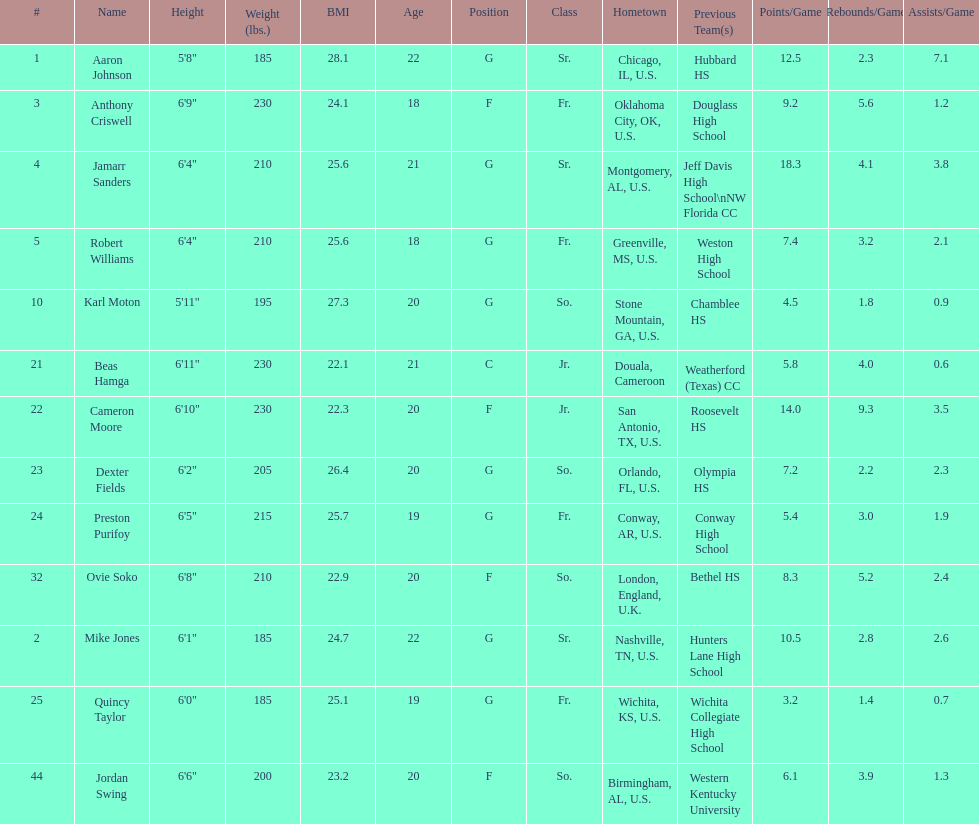Other than soko, tell me a player who is not from the us. Beas Hamga. 